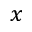Convert formula to latex. <formula><loc_0><loc_0><loc_500><loc_500>x</formula> 